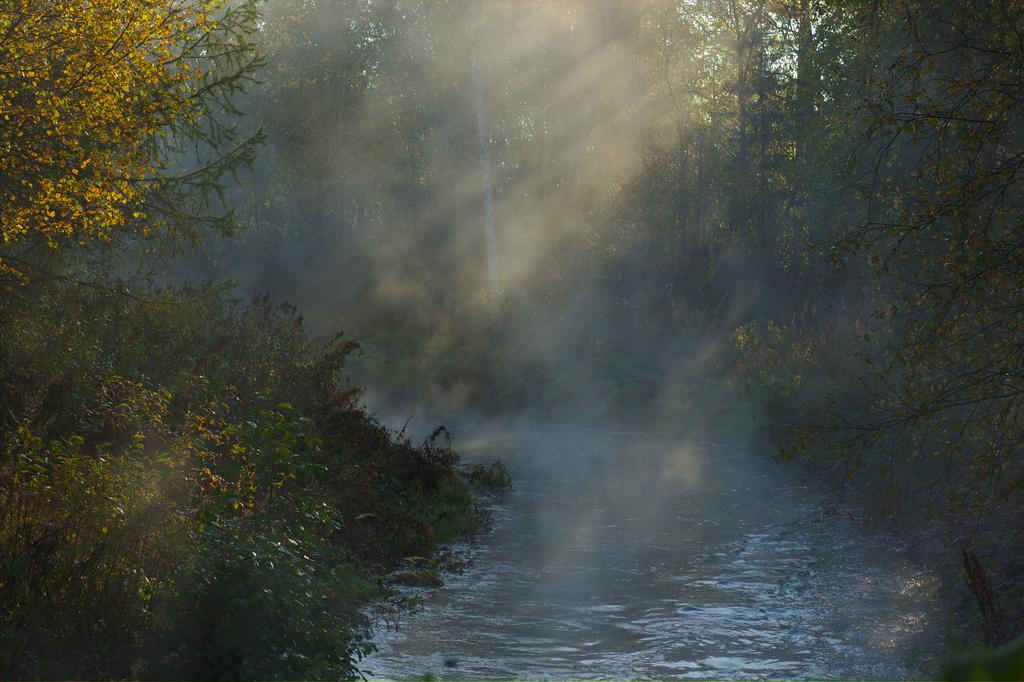What type of vegetation is visible in the front of the image? There are trees in the front of the image. What natural element is present in the center of the image? There is water in the center of the image. What type of vegetation is visible in the background of the image? There are trees in the background of the image. What type of battle is taking place in the image? There is no battle present in the image; it features trees and water. What force is responsible for the presence of the trees in the image? The question assumes the presence of a force, but the image does not provide any information about how the trees got there. 